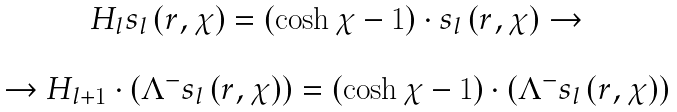Convert formula to latex. <formula><loc_0><loc_0><loc_500><loc_500>\begin{array} { c } H _ { l } s _ { l } \left ( r , \chi \right ) = \left ( \cosh \chi - 1 \right ) \cdot s _ { l } \left ( r , \chi \right ) \rightarrow \\ \\ \rightarrow H _ { l + 1 } \cdot \left ( \Lambda ^ { - } s _ { l } \left ( r , \chi \right ) \right ) = \left ( \cosh \chi - 1 \right ) \cdot \left ( \Lambda ^ { - } s _ { l } \left ( r , \chi \right ) \right ) \end{array}</formula> 